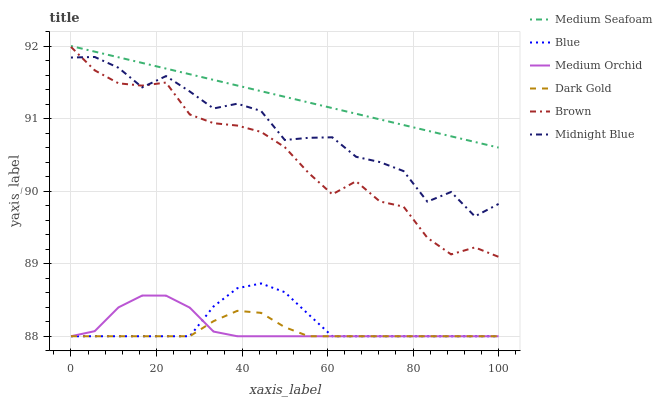Does Dark Gold have the minimum area under the curve?
Answer yes or no. Yes. Does Medium Seafoam have the maximum area under the curve?
Answer yes or no. Yes. Does Brown have the minimum area under the curve?
Answer yes or no. No. Does Brown have the maximum area under the curve?
Answer yes or no. No. Is Medium Seafoam the smoothest?
Answer yes or no. Yes. Is Midnight Blue the roughest?
Answer yes or no. Yes. Is Brown the smoothest?
Answer yes or no. No. Is Brown the roughest?
Answer yes or no. No. Does Blue have the lowest value?
Answer yes or no. Yes. Does Brown have the lowest value?
Answer yes or no. No. Does Medium Seafoam have the highest value?
Answer yes or no. Yes. Does Brown have the highest value?
Answer yes or no. No. Is Blue less than Medium Seafoam?
Answer yes or no. Yes. Is Medium Seafoam greater than Dark Gold?
Answer yes or no. Yes. Does Blue intersect Dark Gold?
Answer yes or no. Yes. Is Blue less than Dark Gold?
Answer yes or no. No. Is Blue greater than Dark Gold?
Answer yes or no. No. Does Blue intersect Medium Seafoam?
Answer yes or no. No. 